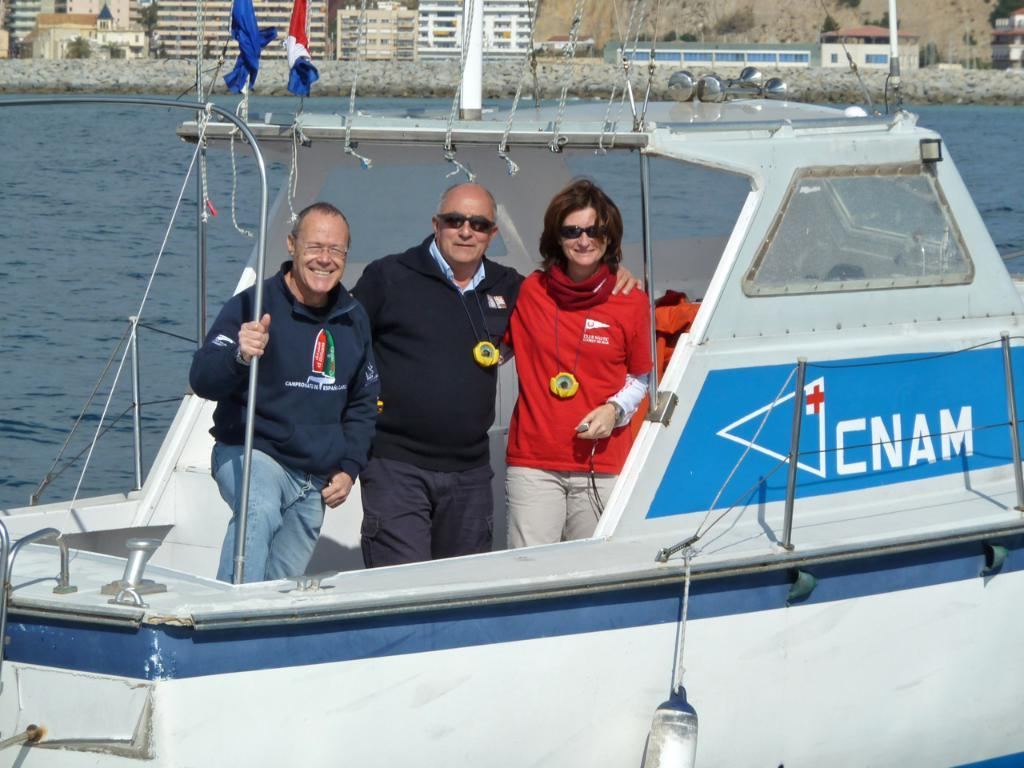<image>
Summarize the visual content of the image. A family posing on a boat that says CNAM. 